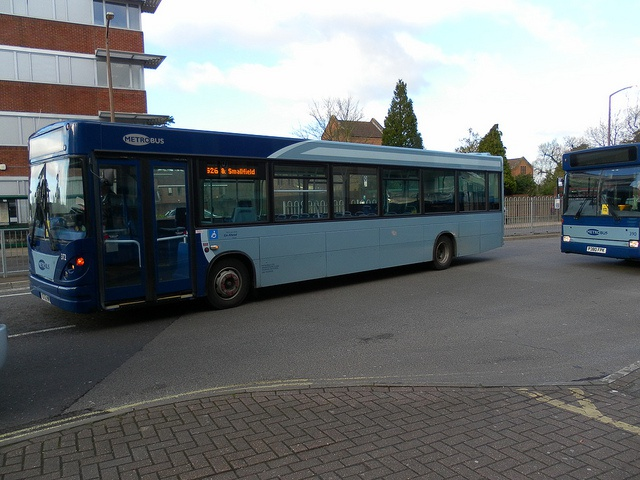Describe the objects in this image and their specific colors. I can see bus in darkgray, black, gray, navy, and blue tones, bus in darkgray, black, navy, gray, and purple tones, and people in darkgray, gray, black, and darkgreen tones in this image. 